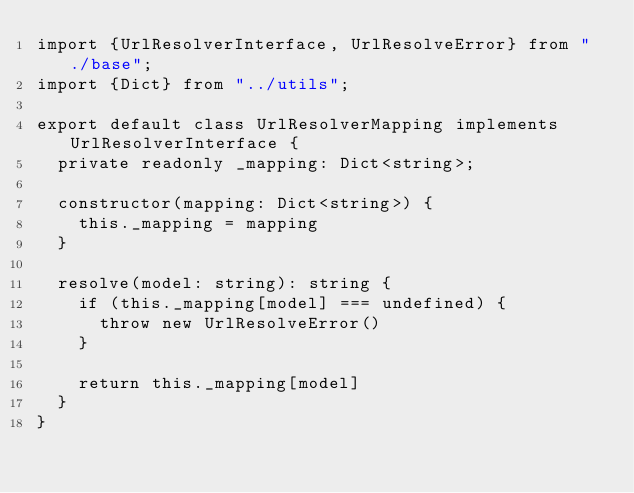<code> <loc_0><loc_0><loc_500><loc_500><_TypeScript_>import {UrlResolverInterface, UrlResolveError} from "./base";
import {Dict} from "../utils";

export default class UrlResolverMapping implements UrlResolverInterface {
  private readonly _mapping: Dict<string>;

  constructor(mapping: Dict<string>) {
    this._mapping = mapping
  }

  resolve(model: string): string {
    if (this._mapping[model] === undefined) {
      throw new UrlResolveError()
    }

    return this._mapping[model]
  }
}
</code> 